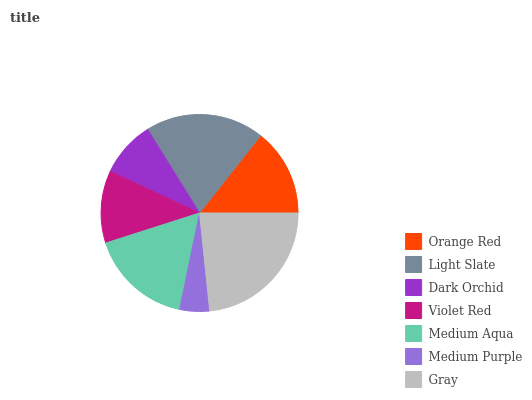Is Medium Purple the minimum?
Answer yes or no. Yes. Is Gray the maximum?
Answer yes or no. Yes. Is Light Slate the minimum?
Answer yes or no. No. Is Light Slate the maximum?
Answer yes or no. No. Is Light Slate greater than Orange Red?
Answer yes or no. Yes. Is Orange Red less than Light Slate?
Answer yes or no. Yes. Is Orange Red greater than Light Slate?
Answer yes or no. No. Is Light Slate less than Orange Red?
Answer yes or no. No. Is Orange Red the high median?
Answer yes or no. Yes. Is Orange Red the low median?
Answer yes or no. Yes. Is Dark Orchid the high median?
Answer yes or no. No. Is Gray the low median?
Answer yes or no. No. 